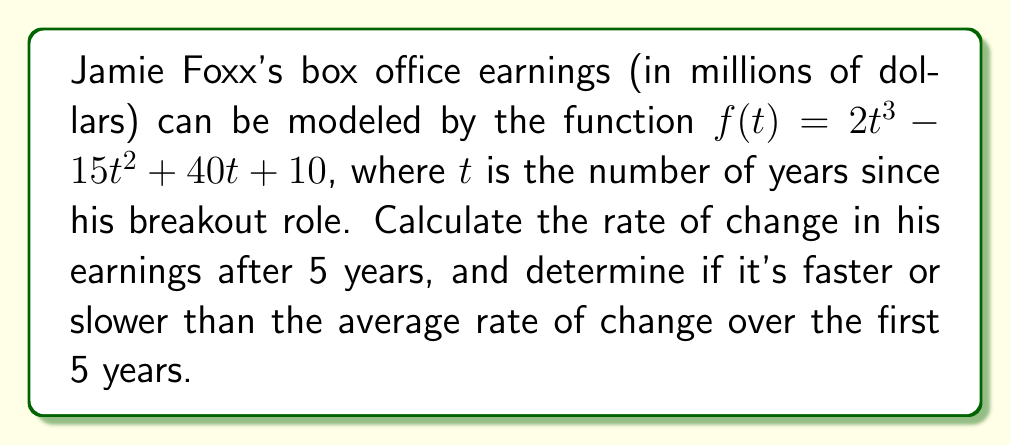Provide a solution to this math problem. 1. To find the rate of change after 5 years, we need to calculate the derivative of $f(t)$ and evaluate it at $t=5$:

   $$f'(t) = 6t^2 - 30t + 40$$
   $$f'(5) = 6(5^2) - 30(5) + 40 = 150 - 150 + 40 = 40$$

2. To find the average rate of change over the first 5 years:
   $$\text{Average rate of change} = \frac{f(5) - f(0)}{5 - 0}$$

3. Calculate $f(5)$ and $f(0)$:
   $$f(5) = 2(5^3) - 15(5^2) + 40(5) + 10 = 250 - 375 + 200 + 10 = 85$$
   $$f(0) = 10$$

4. Now calculate the average rate of change:
   $$\frac{f(5) - f(0)}{5 - 0} = \frac{85 - 10}{5} = 15$$

5. Compare the instantaneous rate of change at $t=5$ (40) to the average rate of change over the first 5 years (15):
   40 > 15, so the rate of change is faster at $t=5$ than the average over the first 5 years.
Answer: $40$ million/year; faster 